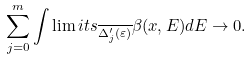<formula> <loc_0><loc_0><loc_500><loc_500>\sum _ { j = 0 } ^ { m } \int \lim i t s _ { \overline { \Delta _ { j } ^ { \prime } ( \varepsilon ) } } \beta ( x , E ) d E \to 0 .</formula> 